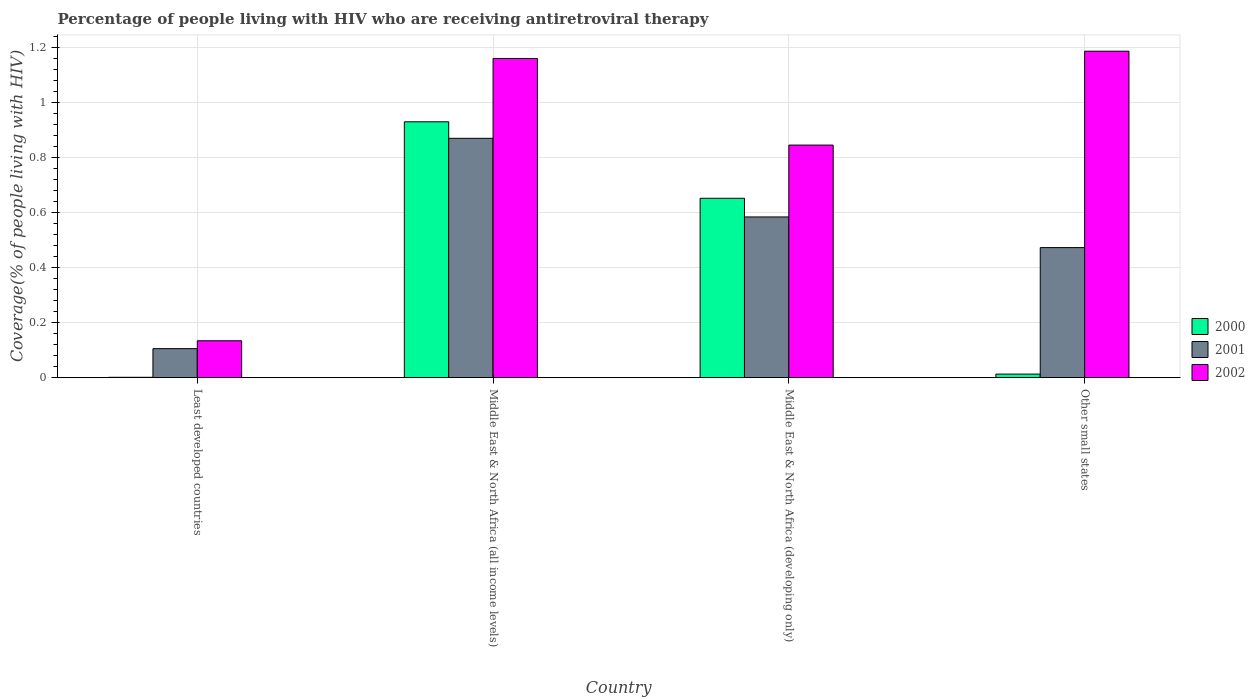How many different coloured bars are there?
Keep it short and to the point. 3. Are the number of bars per tick equal to the number of legend labels?
Your answer should be compact. Yes. How many bars are there on the 1st tick from the left?
Your answer should be compact. 3. How many bars are there on the 3rd tick from the right?
Offer a terse response. 3. What is the label of the 3rd group of bars from the left?
Give a very brief answer. Middle East & North Africa (developing only). What is the percentage of the HIV infected people who are receiving antiretroviral therapy in 2002 in Least developed countries?
Your answer should be very brief. 0.13. Across all countries, what is the maximum percentage of the HIV infected people who are receiving antiretroviral therapy in 2001?
Offer a very short reply. 0.87. Across all countries, what is the minimum percentage of the HIV infected people who are receiving antiretroviral therapy in 2002?
Provide a succinct answer. 0.13. In which country was the percentage of the HIV infected people who are receiving antiretroviral therapy in 2000 maximum?
Provide a succinct answer. Middle East & North Africa (all income levels). In which country was the percentage of the HIV infected people who are receiving antiretroviral therapy in 2000 minimum?
Your response must be concise. Least developed countries. What is the total percentage of the HIV infected people who are receiving antiretroviral therapy in 2002 in the graph?
Give a very brief answer. 3.33. What is the difference between the percentage of the HIV infected people who are receiving antiretroviral therapy in 2002 in Least developed countries and that in Other small states?
Keep it short and to the point. -1.05. What is the difference between the percentage of the HIV infected people who are receiving antiretroviral therapy in 2002 in Middle East & North Africa (all income levels) and the percentage of the HIV infected people who are receiving antiretroviral therapy in 2001 in Least developed countries?
Make the answer very short. 1.05. What is the average percentage of the HIV infected people who are receiving antiretroviral therapy in 2001 per country?
Offer a very short reply. 0.51. What is the difference between the percentage of the HIV infected people who are receiving antiretroviral therapy of/in 2002 and percentage of the HIV infected people who are receiving antiretroviral therapy of/in 2001 in Middle East & North Africa (all income levels)?
Ensure brevity in your answer.  0.29. What is the ratio of the percentage of the HIV infected people who are receiving antiretroviral therapy in 2000 in Middle East & North Africa (all income levels) to that in Other small states?
Give a very brief answer. 71.51. Is the difference between the percentage of the HIV infected people who are receiving antiretroviral therapy in 2002 in Least developed countries and Middle East & North Africa (all income levels) greater than the difference between the percentage of the HIV infected people who are receiving antiretroviral therapy in 2001 in Least developed countries and Middle East & North Africa (all income levels)?
Offer a terse response. No. What is the difference between the highest and the second highest percentage of the HIV infected people who are receiving antiretroviral therapy in 2000?
Your response must be concise. 0.28. What is the difference between the highest and the lowest percentage of the HIV infected people who are receiving antiretroviral therapy in 2001?
Ensure brevity in your answer.  0.76. In how many countries, is the percentage of the HIV infected people who are receiving antiretroviral therapy in 2002 greater than the average percentage of the HIV infected people who are receiving antiretroviral therapy in 2002 taken over all countries?
Offer a very short reply. 3. Is the sum of the percentage of the HIV infected people who are receiving antiretroviral therapy in 2002 in Least developed countries and Middle East & North Africa (all income levels) greater than the maximum percentage of the HIV infected people who are receiving antiretroviral therapy in 2001 across all countries?
Offer a very short reply. Yes. What does the 1st bar from the left in Middle East & North Africa (all income levels) represents?
Your response must be concise. 2000. Is it the case that in every country, the sum of the percentage of the HIV infected people who are receiving antiretroviral therapy in 2001 and percentage of the HIV infected people who are receiving antiretroviral therapy in 2002 is greater than the percentage of the HIV infected people who are receiving antiretroviral therapy in 2000?
Offer a very short reply. Yes. How many bars are there?
Offer a very short reply. 12. Are all the bars in the graph horizontal?
Your answer should be very brief. No. How many countries are there in the graph?
Offer a very short reply. 4. What is the difference between two consecutive major ticks on the Y-axis?
Keep it short and to the point. 0.2. Are the values on the major ticks of Y-axis written in scientific E-notation?
Your answer should be compact. No. Does the graph contain any zero values?
Provide a succinct answer. No. How many legend labels are there?
Make the answer very short. 3. How are the legend labels stacked?
Give a very brief answer. Vertical. What is the title of the graph?
Your response must be concise. Percentage of people living with HIV who are receiving antiretroviral therapy. Does "1969" appear as one of the legend labels in the graph?
Keep it short and to the point. No. What is the label or title of the X-axis?
Your answer should be very brief. Country. What is the label or title of the Y-axis?
Offer a very short reply. Coverage(% of people living with HIV). What is the Coverage(% of people living with HIV) in 2000 in Least developed countries?
Your response must be concise. 0. What is the Coverage(% of people living with HIV) in 2001 in Least developed countries?
Your answer should be compact. 0.11. What is the Coverage(% of people living with HIV) in 2002 in Least developed countries?
Offer a very short reply. 0.13. What is the Coverage(% of people living with HIV) in 2000 in Middle East & North Africa (all income levels)?
Give a very brief answer. 0.93. What is the Coverage(% of people living with HIV) in 2001 in Middle East & North Africa (all income levels)?
Give a very brief answer. 0.87. What is the Coverage(% of people living with HIV) of 2002 in Middle East & North Africa (all income levels)?
Your answer should be very brief. 1.16. What is the Coverage(% of people living with HIV) in 2000 in Middle East & North Africa (developing only)?
Offer a very short reply. 0.65. What is the Coverage(% of people living with HIV) in 2001 in Middle East & North Africa (developing only)?
Your response must be concise. 0.58. What is the Coverage(% of people living with HIV) in 2002 in Middle East & North Africa (developing only)?
Your response must be concise. 0.85. What is the Coverage(% of people living with HIV) in 2000 in Other small states?
Ensure brevity in your answer.  0.01. What is the Coverage(% of people living with HIV) in 2001 in Other small states?
Your response must be concise. 0.47. What is the Coverage(% of people living with HIV) in 2002 in Other small states?
Provide a succinct answer. 1.19. Across all countries, what is the maximum Coverage(% of people living with HIV) in 2000?
Keep it short and to the point. 0.93. Across all countries, what is the maximum Coverage(% of people living with HIV) in 2001?
Make the answer very short. 0.87. Across all countries, what is the maximum Coverage(% of people living with HIV) in 2002?
Your answer should be very brief. 1.19. Across all countries, what is the minimum Coverage(% of people living with HIV) in 2000?
Keep it short and to the point. 0. Across all countries, what is the minimum Coverage(% of people living with HIV) in 2001?
Provide a short and direct response. 0.11. Across all countries, what is the minimum Coverage(% of people living with HIV) in 2002?
Give a very brief answer. 0.13. What is the total Coverage(% of people living with HIV) of 2000 in the graph?
Your answer should be very brief. 1.6. What is the total Coverage(% of people living with HIV) of 2001 in the graph?
Your answer should be very brief. 2.03. What is the total Coverage(% of people living with HIV) in 2002 in the graph?
Give a very brief answer. 3.33. What is the difference between the Coverage(% of people living with HIV) in 2000 in Least developed countries and that in Middle East & North Africa (all income levels)?
Offer a terse response. -0.93. What is the difference between the Coverage(% of people living with HIV) of 2001 in Least developed countries and that in Middle East & North Africa (all income levels)?
Your answer should be very brief. -0.76. What is the difference between the Coverage(% of people living with HIV) in 2002 in Least developed countries and that in Middle East & North Africa (all income levels)?
Offer a very short reply. -1.03. What is the difference between the Coverage(% of people living with HIV) in 2000 in Least developed countries and that in Middle East & North Africa (developing only)?
Offer a very short reply. -0.65. What is the difference between the Coverage(% of people living with HIV) in 2001 in Least developed countries and that in Middle East & North Africa (developing only)?
Your response must be concise. -0.48. What is the difference between the Coverage(% of people living with HIV) of 2002 in Least developed countries and that in Middle East & North Africa (developing only)?
Give a very brief answer. -0.71. What is the difference between the Coverage(% of people living with HIV) of 2000 in Least developed countries and that in Other small states?
Provide a succinct answer. -0.01. What is the difference between the Coverage(% of people living with HIV) of 2001 in Least developed countries and that in Other small states?
Offer a terse response. -0.37. What is the difference between the Coverage(% of people living with HIV) in 2002 in Least developed countries and that in Other small states?
Offer a very short reply. -1.05. What is the difference between the Coverage(% of people living with HIV) in 2000 in Middle East & North Africa (all income levels) and that in Middle East & North Africa (developing only)?
Your answer should be compact. 0.28. What is the difference between the Coverage(% of people living with HIV) in 2001 in Middle East & North Africa (all income levels) and that in Middle East & North Africa (developing only)?
Offer a terse response. 0.29. What is the difference between the Coverage(% of people living with HIV) in 2002 in Middle East & North Africa (all income levels) and that in Middle East & North Africa (developing only)?
Offer a terse response. 0.31. What is the difference between the Coverage(% of people living with HIV) in 2000 in Middle East & North Africa (all income levels) and that in Other small states?
Give a very brief answer. 0.92. What is the difference between the Coverage(% of people living with HIV) in 2001 in Middle East & North Africa (all income levels) and that in Other small states?
Offer a very short reply. 0.4. What is the difference between the Coverage(% of people living with HIV) in 2002 in Middle East & North Africa (all income levels) and that in Other small states?
Your answer should be compact. -0.03. What is the difference between the Coverage(% of people living with HIV) of 2000 in Middle East & North Africa (developing only) and that in Other small states?
Offer a very short reply. 0.64. What is the difference between the Coverage(% of people living with HIV) of 2001 in Middle East & North Africa (developing only) and that in Other small states?
Offer a terse response. 0.11. What is the difference between the Coverage(% of people living with HIV) in 2002 in Middle East & North Africa (developing only) and that in Other small states?
Ensure brevity in your answer.  -0.34. What is the difference between the Coverage(% of people living with HIV) in 2000 in Least developed countries and the Coverage(% of people living with HIV) in 2001 in Middle East & North Africa (all income levels)?
Provide a short and direct response. -0.87. What is the difference between the Coverage(% of people living with HIV) in 2000 in Least developed countries and the Coverage(% of people living with HIV) in 2002 in Middle East & North Africa (all income levels)?
Your answer should be compact. -1.16. What is the difference between the Coverage(% of people living with HIV) in 2001 in Least developed countries and the Coverage(% of people living with HIV) in 2002 in Middle East & North Africa (all income levels)?
Your answer should be very brief. -1.05. What is the difference between the Coverage(% of people living with HIV) in 2000 in Least developed countries and the Coverage(% of people living with HIV) in 2001 in Middle East & North Africa (developing only)?
Your response must be concise. -0.58. What is the difference between the Coverage(% of people living with HIV) of 2000 in Least developed countries and the Coverage(% of people living with HIV) of 2002 in Middle East & North Africa (developing only)?
Provide a short and direct response. -0.84. What is the difference between the Coverage(% of people living with HIV) in 2001 in Least developed countries and the Coverage(% of people living with HIV) in 2002 in Middle East & North Africa (developing only)?
Provide a short and direct response. -0.74. What is the difference between the Coverage(% of people living with HIV) of 2000 in Least developed countries and the Coverage(% of people living with HIV) of 2001 in Other small states?
Keep it short and to the point. -0.47. What is the difference between the Coverage(% of people living with HIV) of 2000 in Least developed countries and the Coverage(% of people living with HIV) of 2002 in Other small states?
Make the answer very short. -1.19. What is the difference between the Coverage(% of people living with HIV) of 2001 in Least developed countries and the Coverage(% of people living with HIV) of 2002 in Other small states?
Your response must be concise. -1.08. What is the difference between the Coverage(% of people living with HIV) in 2000 in Middle East & North Africa (all income levels) and the Coverage(% of people living with HIV) in 2001 in Middle East & North Africa (developing only)?
Give a very brief answer. 0.35. What is the difference between the Coverage(% of people living with HIV) of 2000 in Middle East & North Africa (all income levels) and the Coverage(% of people living with HIV) of 2002 in Middle East & North Africa (developing only)?
Offer a terse response. 0.08. What is the difference between the Coverage(% of people living with HIV) in 2001 in Middle East & North Africa (all income levels) and the Coverage(% of people living with HIV) in 2002 in Middle East & North Africa (developing only)?
Offer a very short reply. 0.02. What is the difference between the Coverage(% of people living with HIV) in 2000 in Middle East & North Africa (all income levels) and the Coverage(% of people living with HIV) in 2001 in Other small states?
Your answer should be very brief. 0.46. What is the difference between the Coverage(% of people living with HIV) in 2000 in Middle East & North Africa (all income levels) and the Coverage(% of people living with HIV) in 2002 in Other small states?
Make the answer very short. -0.26. What is the difference between the Coverage(% of people living with HIV) of 2001 in Middle East & North Africa (all income levels) and the Coverage(% of people living with HIV) of 2002 in Other small states?
Offer a very short reply. -0.32. What is the difference between the Coverage(% of people living with HIV) in 2000 in Middle East & North Africa (developing only) and the Coverage(% of people living with HIV) in 2001 in Other small states?
Your response must be concise. 0.18. What is the difference between the Coverage(% of people living with HIV) in 2000 in Middle East & North Africa (developing only) and the Coverage(% of people living with HIV) in 2002 in Other small states?
Offer a terse response. -0.53. What is the difference between the Coverage(% of people living with HIV) in 2001 in Middle East & North Africa (developing only) and the Coverage(% of people living with HIV) in 2002 in Other small states?
Your answer should be compact. -0.6. What is the average Coverage(% of people living with HIV) in 2000 per country?
Ensure brevity in your answer.  0.4. What is the average Coverage(% of people living with HIV) in 2001 per country?
Offer a terse response. 0.51. What is the average Coverage(% of people living with HIV) of 2002 per country?
Keep it short and to the point. 0.83. What is the difference between the Coverage(% of people living with HIV) in 2000 and Coverage(% of people living with HIV) in 2001 in Least developed countries?
Provide a short and direct response. -0.1. What is the difference between the Coverage(% of people living with HIV) in 2000 and Coverage(% of people living with HIV) in 2002 in Least developed countries?
Ensure brevity in your answer.  -0.13. What is the difference between the Coverage(% of people living with HIV) of 2001 and Coverage(% of people living with HIV) of 2002 in Least developed countries?
Provide a succinct answer. -0.03. What is the difference between the Coverage(% of people living with HIV) in 2000 and Coverage(% of people living with HIV) in 2001 in Middle East & North Africa (all income levels)?
Ensure brevity in your answer.  0.06. What is the difference between the Coverage(% of people living with HIV) in 2000 and Coverage(% of people living with HIV) in 2002 in Middle East & North Africa (all income levels)?
Your answer should be compact. -0.23. What is the difference between the Coverage(% of people living with HIV) in 2001 and Coverage(% of people living with HIV) in 2002 in Middle East & North Africa (all income levels)?
Make the answer very short. -0.29. What is the difference between the Coverage(% of people living with HIV) in 2000 and Coverage(% of people living with HIV) in 2001 in Middle East & North Africa (developing only)?
Your answer should be very brief. 0.07. What is the difference between the Coverage(% of people living with HIV) in 2000 and Coverage(% of people living with HIV) in 2002 in Middle East & North Africa (developing only)?
Your response must be concise. -0.19. What is the difference between the Coverage(% of people living with HIV) of 2001 and Coverage(% of people living with HIV) of 2002 in Middle East & North Africa (developing only)?
Provide a short and direct response. -0.26. What is the difference between the Coverage(% of people living with HIV) of 2000 and Coverage(% of people living with HIV) of 2001 in Other small states?
Make the answer very short. -0.46. What is the difference between the Coverage(% of people living with HIV) in 2000 and Coverage(% of people living with HIV) in 2002 in Other small states?
Your answer should be very brief. -1.17. What is the difference between the Coverage(% of people living with HIV) of 2001 and Coverage(% of people living with HIV) of 2002 in Other small states?
Provide a short and direct response. -0.71. What is the ratio of the Coverage(% of people living with HIV) of 2000 in Least developed countries to that in Middle East & North Africa (all income levels)?
Offer a very short reply. 0. What is the ratio of the Coverage(% of people living with HIV) of 2001 in Least developed countries to that in Middle East & North Africa (all income levels)?
Your response must be concise. 0.12. What is the ratio of the Coverage(% of people living with HIV) in 2002 in Least developed countries to that in Middle East & North Africa (all income levels)?
Your answer should be very brief. 0.12. What is the ratio of the Coverage(% of people living with HIV) of 2000 in Least developed countries to that in Middle East & North Africa (developing only)?
Provide a succinct answer. 0. What is the ratio of the Coverage(% of people living with HIV) in 2001 in Least developed countries to that in Middle East & North Africa (developing only)?
Give a very brief answer. 0.18. What is the ratio of the Coverage(% of people living with HIV) of 2002 in Least developed countries to that in Middle East & North Africa (developing only)?
Give a very brief answer. 0.16. What is the ratio of the Coverage(% of people living with HIV) in 2000 in Least developed countries to that in Other small states?
Offer a very short reply. 0.1. What is the ratio of the Coverage(% of people living with HIV) of 2001 in Least developed countries to that in Other small states?
Provide a succinct answer. 0.22. What is the ratio of the Coverage(% of people living with HIV) in 2002 in Least developed countries to that in Other small states?
Keep it short and to the point. 0.11. What is the ratio of the Coverage(% of people living with HIV) of 2000 in Middle East & North Africa (all income levels) to that in Middle East & North Africa (developing only)?
Keep it short and to the point. 1.43. What is the ratio of the Coverage(% of people living with HIV) in 2001 in Middle East & North Africa (all income levels) to that in Middle East & North Africa (developing only)?
Your answer should be very brief. 1.49. What is the ratio of the Coverage(% of people living with HIV) of 2002 in Middle East & North Africa (all income levels) to that in Middle East & North Africa (developing only)?
Your answer should be very brief. 1.37. What is the ratio of the Coverage(% of people living with HIV) in 2000 in Middle East & North Africa (all income levels) to that in Other small states?
Your answer should be very brief. 71.51. What is the ratio of the Coverage(% of people living with HIV) of 2001 in Middle East & North Africa (all income levels) to that in Other small states?
Offer a very short reply. 1.84. What is the ratio of the Coverage(% of people living with HIV) of 2002 in Middle East & North Africa (all income levels) to that in Other small states?
Offer a terse response. 0.98. What is the ratio of the Coverage(% of people living with HIV) of 2000 in Middle East & North Africa (developing only) to that in Other small states?
Offer a very short reply. 50.14. What is the ratio of the Coverage(% of people living with HIV) of 2001 in Middle East & North Africa (developing only) to that in Other small states?
Provide a succinct answer. 1.24. What is the ratio of the Coverage(% of people living with HIV) of 2002 in Middle East & North Africa (developing only) to that in Other small states?
Give a very brief answer. 0.71. What is the difference between the highest and the second highest Coverage(% of people living with HIV) in 2000?
Your answer should be compact. 0.28. What is the difference between the highest and the second highest Coverage(% of people living with HIV) in 2001?
Ensure brevity in your answer.  0.29. What is the difference between the highest and the second highest Coverage(% of people living with HIV) of 2002?
Provide a short and direct response. 0.03. What is the difference between the highest and the lowest Coverage(% of people living with HIV) in 2000?
Give a very brief answer. 0.93. What is the difference between the highest and the lowest Coverage(% of people living with HIV) in 2001?
Offer a terse response. 0.76. What is the difference between the highest and the lowest Coverage(% of people living with HIV) of 2002?
Offer a terse response. 1.05. 